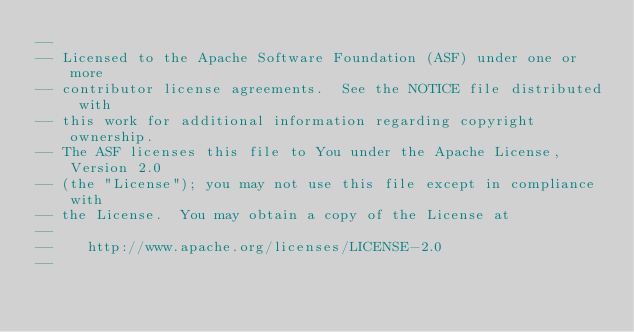<code> <loc_0><loc_0><loc_500><loc_500><_SQL_>--
-- Licensed to the Apache Software Foundation (ASF) under one or more
-- contributor license agreements.  See the NOTICE file distributed with
-- this work for additional information regarding copyright ownership.
-- The ASF licenses this file to You under the Apache License, Version 2.0
-- (the "License"); you may not use this file except in compliance with
-- the License.  You may obtain a copy of the License at
--
--    http://www.apache.org/licenses/LICENSE-2.0
--</code> 